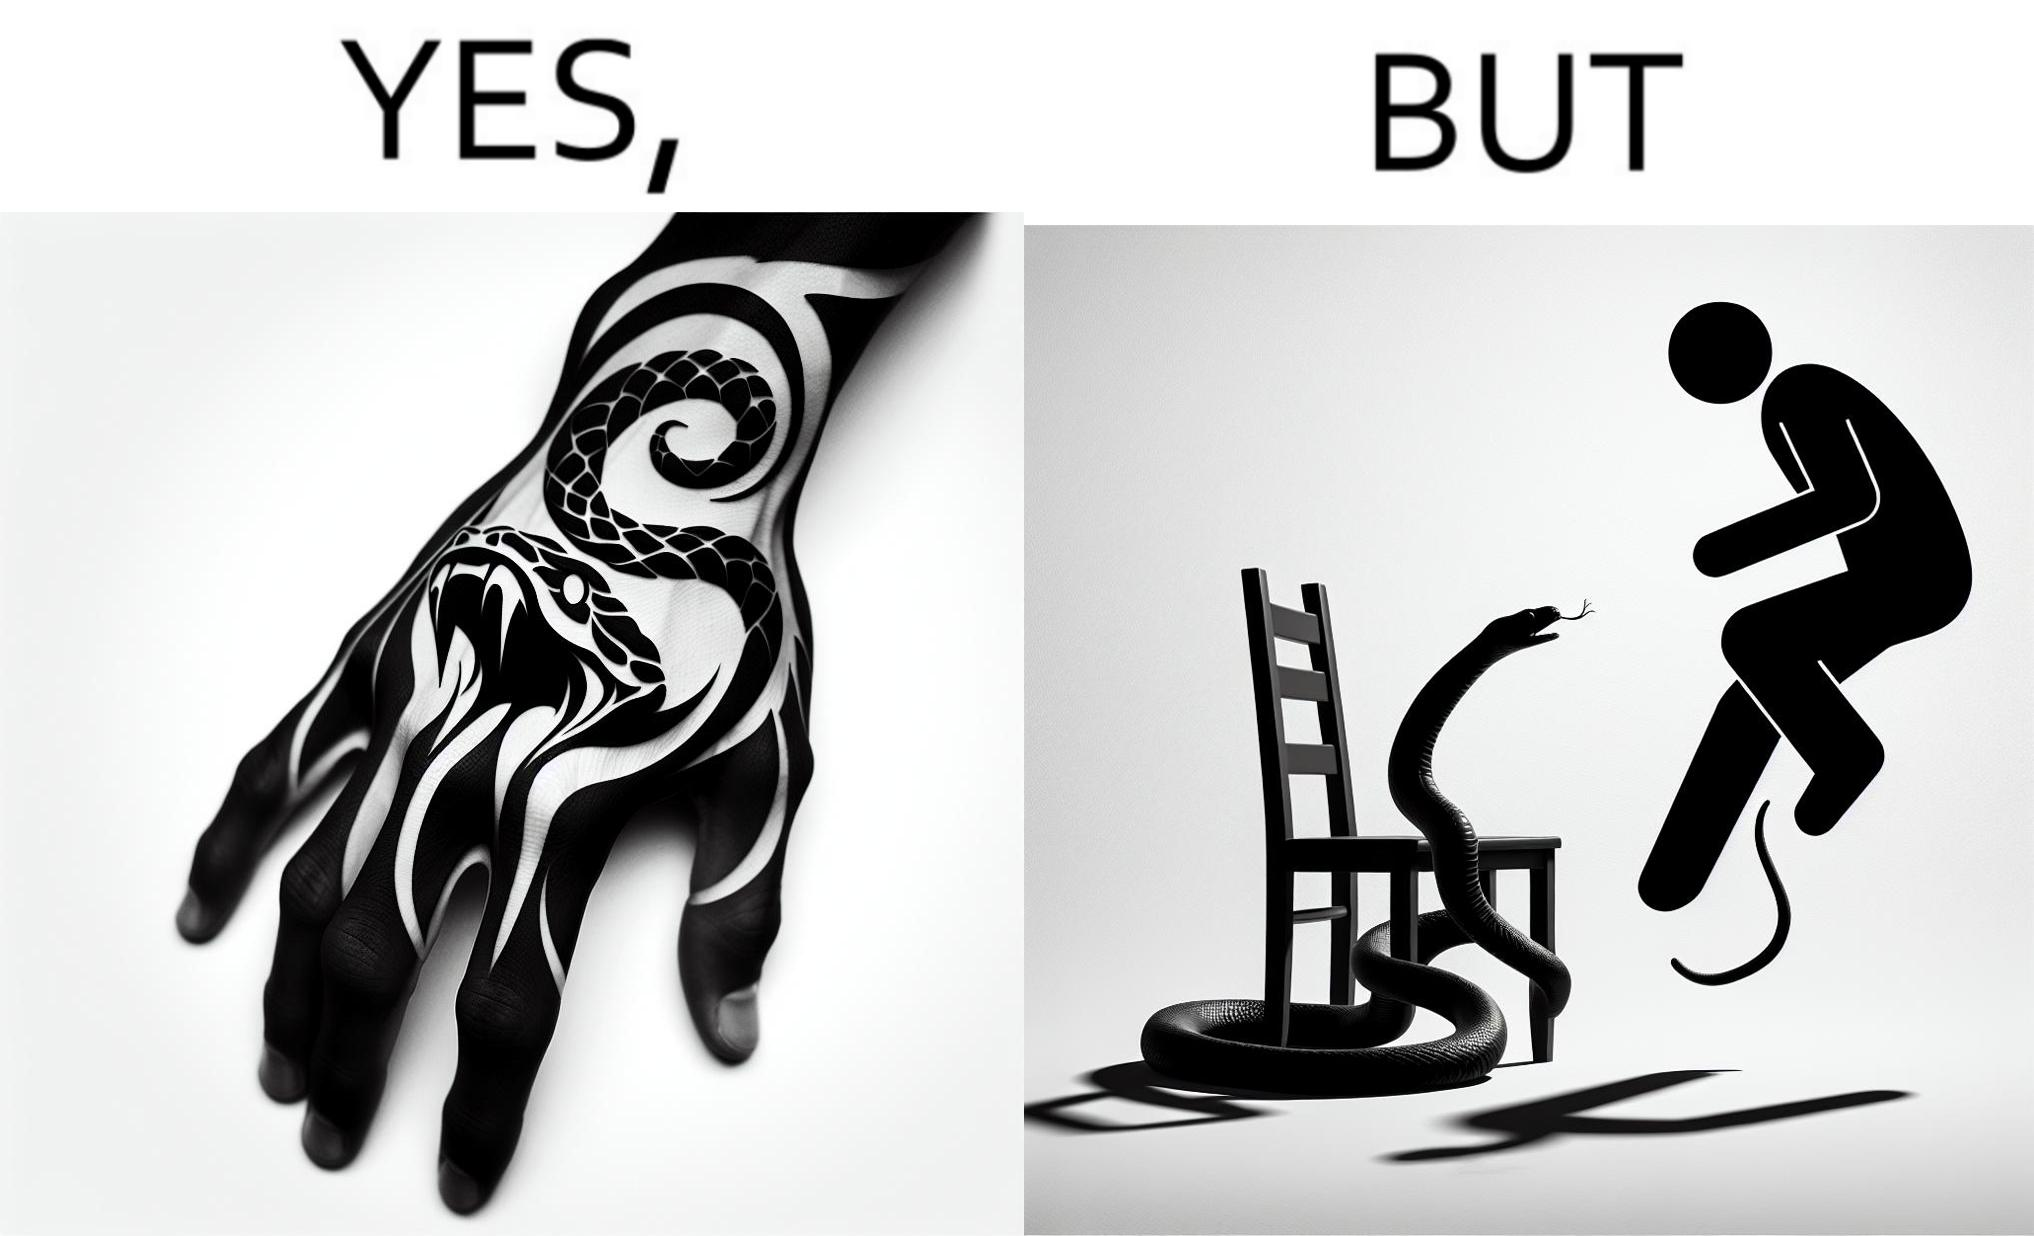Describe the content of this image. The image is ironic, because in the first image the tattoo of a snake on someone's hand may give us a hint about how powerful or brave the person can be who is having this tattoo but in the second image the person with same tattoo is seen frightened due to a snake in his house 